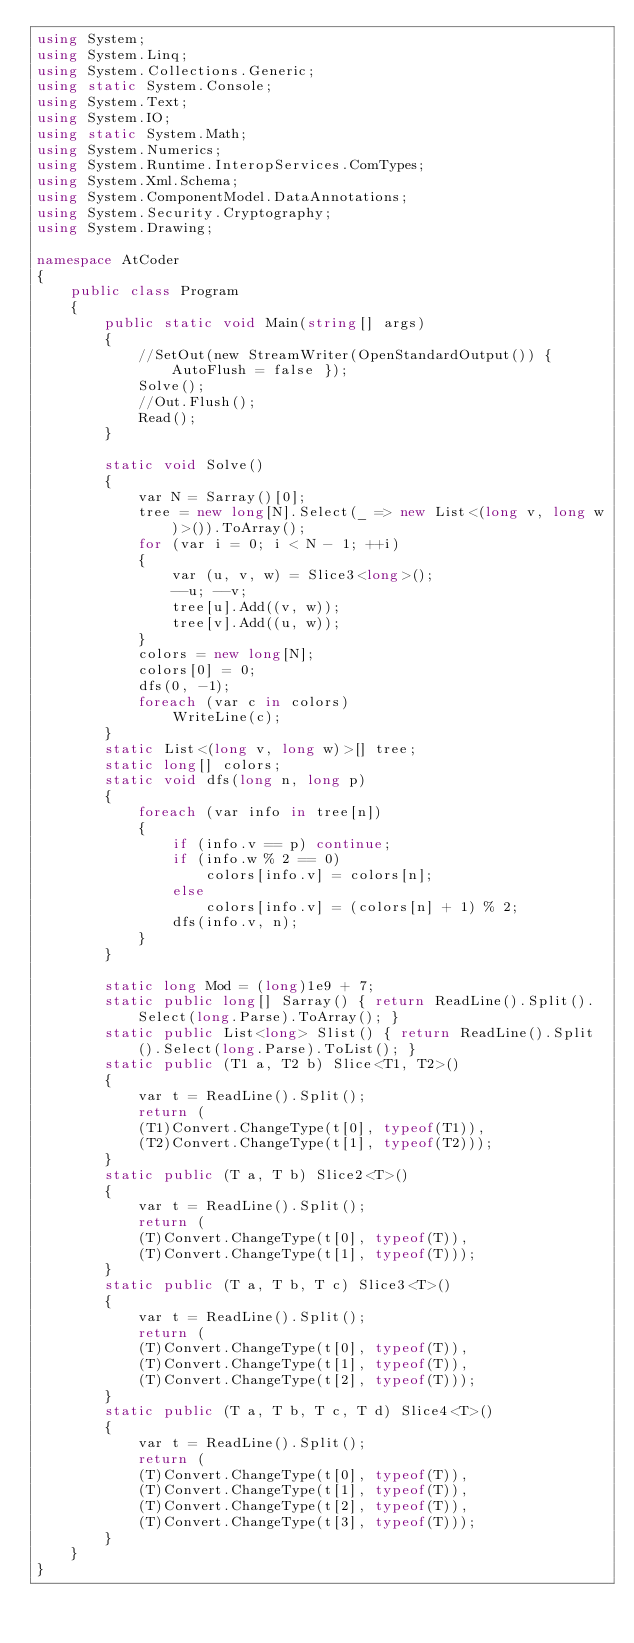<code> <loc_0><loc_0><loc_500><loc_500><_C#_>using System;
using System.Linq;
using System.Collections.Generic;
using static System.Console;
using System.Text;
using System.IO;
using static System.Math;
using System.Numerics;
using System.Runtime.InteropServices.ComTypes;
using System.Xml.Schema;
using System.ComponentModel.DataAnnotations;
using System.Security.Cryptography;
using System.Drawing;

namespace AtCoder
{
    public class Program
    {
        public static void Main(string[] args)
        {
            //SetOut(new StreamWriter(OpenStandardOutput()) { AutoFlush = false });
            Solve();
            //Out.Flush();
            Read();
        }

        static void Solve()
        {
            var N = Sarray()[0];
            tree = new long[N].Select(_ => new List<(long v, long w)>()).ToArray();
            for (var i = 0; i < N - 1; ++i)
            {
                var (u, v, w) = Slice3<long>();
                --u; --v;
                tree[u].Add((v, w));
                tree[v].Add((u, w));
            }
            colors = new long[N];
            colors[0] = 0;
            dfs(0, -1);
            foreach (var c in colors)
                WriteLine(c);
        }
        static List<(long v, long w)>[] tree;
        static long[] colors;
        static void dfs(long n, long p)
        {
            foreach (var info in tree[n])
            {
                if (info.v == p) continue;
                if (info.w % 2 == 0)
                    colors[info.v] = colors[n];
                else
                    colors[info.v] = (colors[n] + 1) % 2;
                dfs(info.v, n);
            }
        }

        static long Mod = (long)1e9 + 7;
        static public long[] Sarray() { return ReadLine().Split().Select(long.Parse).ToArray(); }
        static public List<long> Slist() { return ReadLine().Split().Select(long.Parse).ToList(); }
        static public (T1 a, T2 b) Slice<T1, T2>()
        {
            var t = ReadLine().Split();
            return (
            (T1)Convert.ChangeType(t[0], typeof(T1)),
            (T2)Convert.ChangeType(t[1], typeof(T2)));
        }
        static public (T a, T b) Slice2<T>()
        {
            var t = ReadLine().Split();
            return (
            (T)Convert.ChangeType(t[0], typeof(T)),
            (T)Convert.ChangeType(t[1], typeof(T)));
        }
        static public (T a, T b, T c) Slice3<T>()
        {
            var t = ReadLine().Split();
            return (
            (T)Convert.ChangeType(t[0], typeof(T)),
            (T)Convert.ChangeType(t[1], typeof(T)),
            (T)Convert.ChangeType(t[2], typeof(T)));
        }
        static public (T a, T b, T c, T d) Slice4<T>()
        {
            var t = ReadLine().Split();
            return (
            (T)Convert.ChangeType(t[0], typeof(T)),
            (T)Convert.ChangeType(t[1], typeof(T)),
            (T)Convert.ChangeType(t[2], typeof(T)),
            (T)Convert.ChangeType(t[3], typeof(T)));
        }
    }
}</code> 